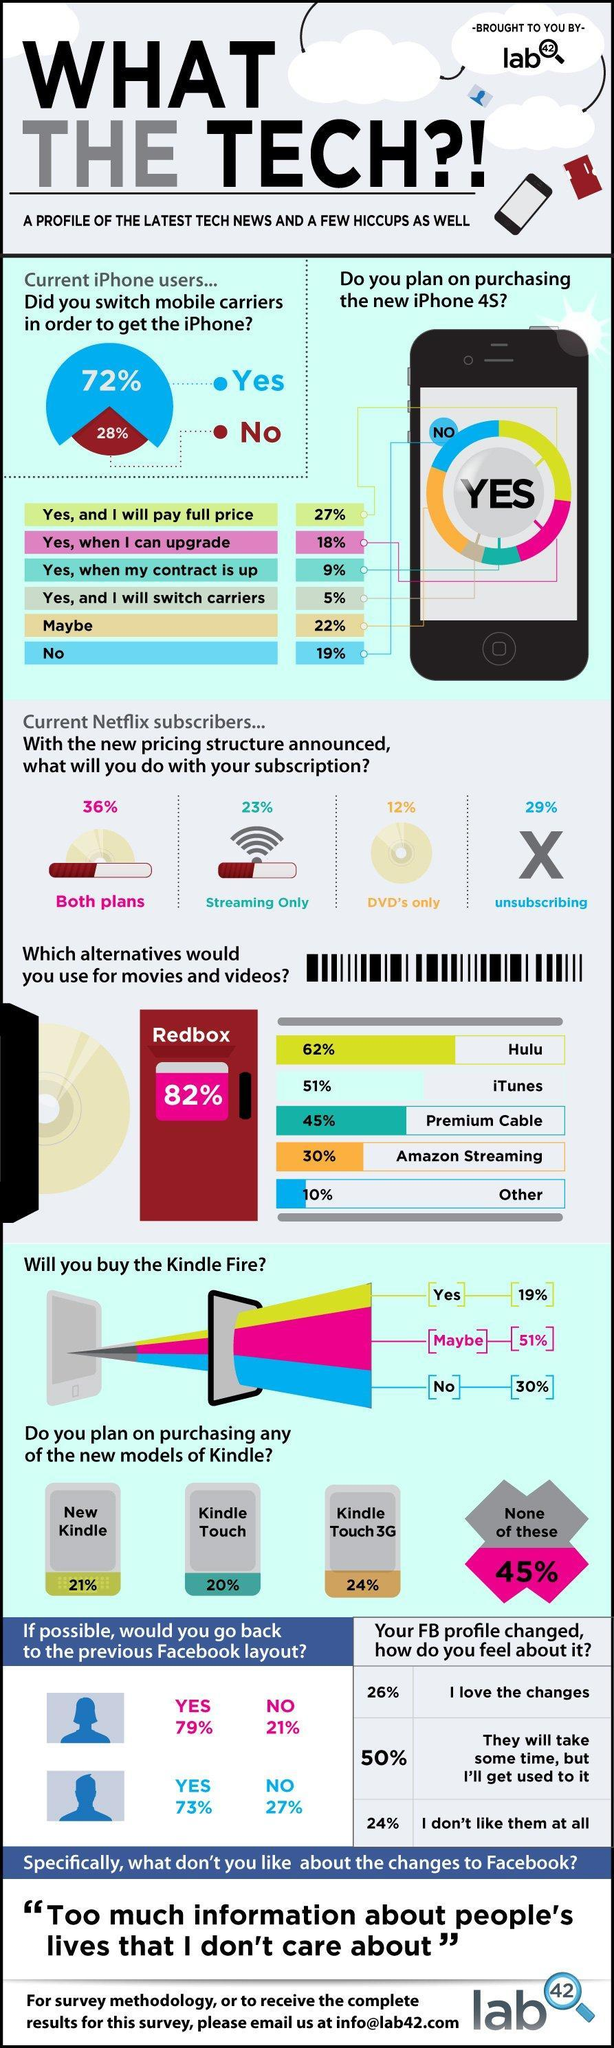What do majority of the respondents use as an alternative to watch movies & videos as per the survey?
Answer the question with a short phrase. Redbox What percent of the current Netflix subscribers do only streaming with the subscription? 23% What percent of respondents plan to buy Kindle Touch as per the survey? 20% What percentage of current iPhone users have no plan to purchase the new iPhone 4S according to the survey? 19% What percent of respondents use Amazon streaming as an alternative to watch movies & videos as per the survey? 30% What percent of respondents will not buy Kindle Fire according to the survey? 30% What percentage of current iPhone users have plan to purchase the new iPhone 4S by paying the full price according to the survey? 27% 